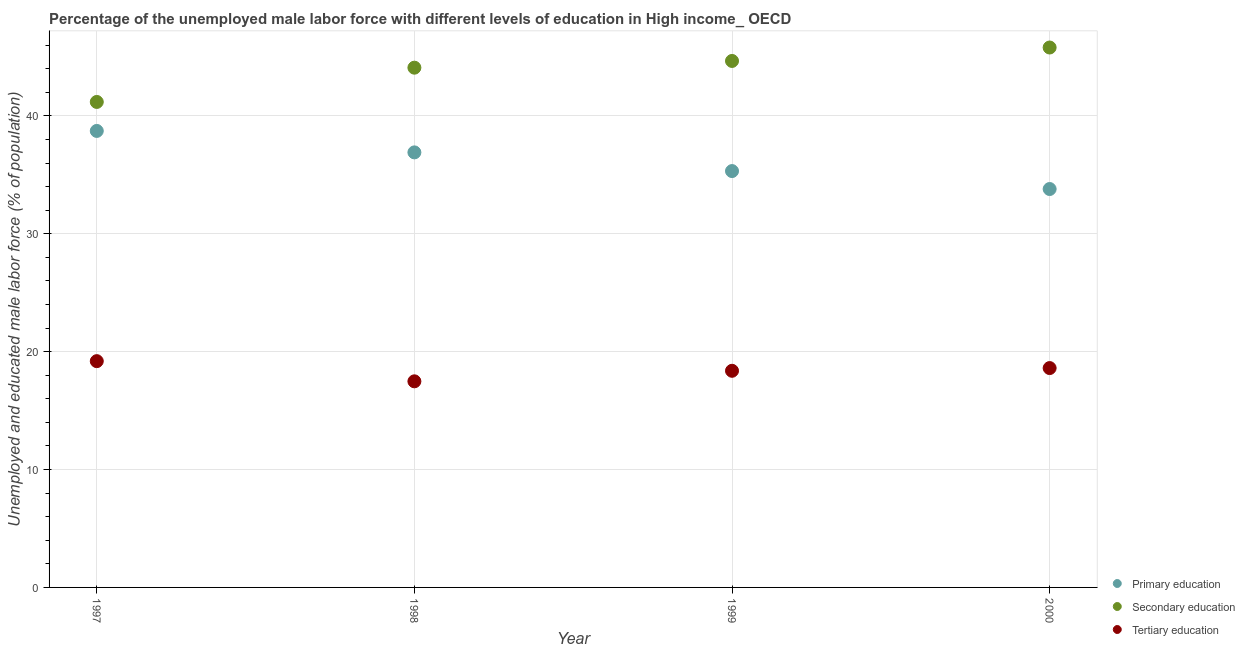Is the number of dotlines equal to the number of legend labels?
Ensure brevity in your answer.  Yes. What is the percentage of male labor force who received secondary education in 2000?
Make the answer very short. 45.8. Across all years, what is the maximum percentage of male labor force who received secondary education?
Provide a short and direct response. 45.8. Across all years, what is the minimum percentage of male labor force who received tertiary education?
Make the answer very short. 17.48. What is the total percentage of male labor force who received secondary education in the graph?
Provide a succinct answer. 175.74. What is the difference between the percentage of male labor force who received primary education in 1998 and that in 2000?
Provide a succinct answer. 3.11. What is the difference between the percentage of male labor force who received primary education in 1997 and the percentage of male labor force who received secondary education in 1999?
Your answer should be compact. -5.94. What is the average percentage of male labor force who received secondary education per year?
Your answer should be compact. 43.93. In the year 1997, what is the difference between the percentage of male labor force who received tertiary education and percentage of male labor force who received secondary education?
Your answer should be very brief. -21.99. In how many years, is the percentage of male labor force who received tertiary education greater than 24 %?
Give a very brief answer. 0. What is the ratio of the percentage of male labor force who received tertiary education in 1998 to that in 1999?
Ensure brevity in your answer.  0.95. Is the percentage of male labor force who received secondary education in 1997 less than that in 1999?
Your answer should be compact. Yes. What is the difference between the highest and the second highest percentage of male labor force who received primary education?
Give a very brief answer. 1.82. What is the difference between the highest and the lowest percentage of male labor force who received primary education?
Offer a very short reply. 4.93. In how many years, is the percentage of male labor force who received secondary education greater than the average percentage of male labor force who received secondary education taken over all years?
Offer a terse response. 3. Is the sum of the percentage of male labor force who received primary education in 1997 and 1998 greater than the maximum percentage of male labor force who received tertiary education across all years?
Provide a succinct answer. Yes. Is it the case that in every year, the sum of the percentage of male labor force who received primary education and percentage of male labor force who received secondary education is greater than the percentage of male labor force who received tertiary education?
Ensure brevity in your answer.  Yes. Is the percentage of male labor force who received primary education strictly greater than the percentage of male labor force who received tertiary education over the years?
Give a very brief answer. Yes. How many years are there in the graph?
Ensure brevity in your answer.  4. Are the values on the major ticks of Y-axis written in scientific E-notation?
Give a very brief answer. No. How many legend labels are there?
Offer a very short reply. 3. How are the legend labels stacked?
Ensure brevity in your answer.  Vertical. What is the title of the graph?
Provide a short and direct response. Percentage of the unemployed male labor force with different levels of education in High income_ OECD. What is the label or title of the Y-axis?
Offer a very short reply. Unemployed and educated male labor force (% of population). What is the Unemployed and educated male labor force (% of population) in Primary education in 1997?
Your response must be concise. 38.73. What is the Unemployed and educated male labor force (% of population) in Secondary education in 1997?
Make the answer very short. 41.18. What is the Unemployed and educated male labor force (% of population) in Tertiary education in 1997?
Your response must be concise. 19.2. What is the Unemployed and educated male labor force (% of population) in Primary education in 1998?
Your response must be concise. 36.91. What is the Unemployed and educated male labor force (% of population) in Secondary education in 1998?
Offer a terse response. 44.09. What is the Unemployed and educated male labor force (% of population) in Tertiary education in 1998?
Your answer should be compact. 17.48. What is the Unemployed and educated male labor force (% of population) of Primary education in 1999?
Give a very brief answer. 35.32. What is the Unemployed and educated male labor force (% of population) in Secondary education in 1999?
Give a very brief answer. 44.66. What is the Unemployed and educated male labor force (% of population) in Tertiary education in 1999?
Ensure brevity in your answer.  18.38. What is the Unemployed and educated male labor force (% of population) of Primary education in 2000?
Keep it short and to the point. 33.8. What is the Unemployed and educated male labor force (% of population) in Secondary education in 2000?
Provide a short and direct response. 45.8. What is the Unemployed and educated male labor force (% of population) of Tertiary education in 2000?
Provide a short and direct response. 18.61. Across all years, what is the maximum Unemployed and educated male labor force (% of population) of Primary education?
Your response must be concise. 38.73. Across all years, what is the maximum Unemployed and educated male labor force (% of population) of Secondary education?
Keep it short and to the point. 45.8. Across all years, what is the maximum Unemployed and educated male labor force (% of population) of Tertiary education?
Keep it short and to the point. 19.2. Across all years, what is the minimum Unemployed and educated male labor force (% of population) of Primary education?
Offer a very short reply. 33.8. Across all years, what is the minimum Unemployed and educated male labor force (% of population) of Secondary education?
Give a very brief answer. 41.18. Across all years, what is the minimum Unemployed and educated male labor force (% of population) in Tertiary education?
Provide a short and direct response. 17.48. What is the total Unemployed and educated male labor force (% of population) in Primary education in the graph?
Keep it short and to the point. 144.75. What is the total Unemployed and educated male labor force (% of population) in Secondary education in the graph?
Ensure brevity in your answer.  175.74. What is the total Unemployed and educated male labor force (% of population) of Tertiary education in the graph?
Your response must be concise. 73.67. What is the difference between the Unemployed and educated male labor force (% of population) of Primary education in 1997 and that in 1998?
Ensure brevity in your answer.  1.82. What is the difference between the Unemployed and educated male labor force (% of population) of Secondary education in 1997 and that in 1998?
Give a very brief answer. -2.91. What is the difference between the Unemployed and educated male labor force (% of population) in Tertiary education in 1997 and that in 1998?
Ensure brevity in your answer.  1.71. What is the difference between the Unemployed and educated male labor force (% of population) in Primary education in 1997 and that in 1999?
Your response must be concise. 3.41. What is the difference between the Unemployed and educated male labor force (% of population) of Secondary education in 1997 and that in 1999?
Your answer should be compact. -3.48. What is the difference between the Unemployed and educated male labor force (% of population) in Tertiary education in 1997 and that in 1999?
Your answer should be compact. 0.82. What is the difference between the Unemployed and educated male labor force (% of population) in Primary education in 1997 and that in 2000?
Give a very brief answer. 4.93. What is the difference between the Unemployed and educated male labor force (% of population) of Secondary education in 1997 and that in 2000?
Your answer should be compact. -4.62. What is the difference between the Unemployed and educated male labor force (% of population) of Tertiary education in 1997 and that in 2000?
Offer a very short reply. 0.59. What is the difference between the Unemployed and educated male labor force (% of population) in Primary education in 1998 and that in 1999?
Give a very brief answer. 1.59. What is the difference between the Unemployed and educated male labor force (% of population) of Secondary education in 1998 and that in 1999?
Make the answer very short. -0.57. What is the difference between the Unemployed and educated male labor force (% of population) of Tertiary education in 1998 and that in 1999?
Offer a terse response. -0.89. What is the difference between the Unemployed and educated male labor force (% of population) of Primary education in 1998 and that in 2000?
Ensure brevity in your answer.  3.11. What is the difference between the Unemployed and educated male labor force (% of population) of Secondary education in 1998 and that in 2000?
Ensure brevity in your answer.  -1.71. What is the difference between the Unemployed and educated male labor force (% of population) in Tertiary education in 1998 and that in 2000?
Provide a short and direct response. -1.12. What is the difference between the Unemployed and educated male labor force (% of population) in Primary education in 1999 and that in 2000?
Your answer should be very brief. 1.52. What is the difference between the Unemployed and educated male labor force (% of population) in Secondary education in 1999 and that in 2000?
Provide a succinct answer. -1.14. What is the difference between the Unemployed and educated male labor force (% of population) of Tertiary education in 1999 and that in 2000?
Offer a very short reply. -0.23. What is the difference between the Unemployed and educated male labor force (% of population) in Primary education in 1997 and the Unemployed and educated male labor force (% of population) in Secondary education in 1998?
Your answer should be very brief. -5.37. What is the difference between the Unemployed and educated male labor force (% of population) of Primary education in 1997 and the Unemployed and educated male labor force (% of population) of Tertiary education in 1998?
Your answer should be compact. 21.24. What is the difference between the Unemployed and educated male labor force (% of population) of Secondary education in 1997 and the Unemployed and educated male labor force (% of population) of Tertiary education in 1998?
Ensure brevity in your answer.  23.7. What is the difference between the Unemployed and educated male labor force (% of population) in Primary education in 1997 and the Unemployed and educated male labor force (% of population) in Secondary education in 1999?
Provide a succinct answer. -5.94. What is the difference between the Unemployed and educated male labor force (% of population) of Primary education in 1997 and the Unemployed and educated male labor force (% of population) of Tertiary education in 1999?
Ensure brevity in your answer.  20.35. What is the difference between the Unemployed and educated male labor force (% of population) of Secondary education in 1997 and the Unemployed and educated male labor force (% of population) of Tertiary education in 1999?
Keep it short and to the point. 22.81. What is the difference between the Unemployed and educated male labor force (% of population) of Primary education in 1997 and the Unemployed and educated male labor force (% of population) of Secondary education in 2000?
Ensure brevity in your answer.  -7.08. What is the difference between the Unemployed and educated male labor force (% of population) of Primary education in 1997 and the Unemployed and educated male labor force (% of population) of Tertiary education in 2000?
Make the answer very short. 20.12. What is the difference between the Unemployed and educated male labor force (% of population) of Secondary education in 1997 and the Unemployed and educated male labor force (% of population) of Tertiary education in 2000?
Provide a short and direct response. 22.58. What is the difference between the Unemployed and educated male labor force (% of population) in Primary education in 1998 and the Unemployed and educated male labor force (% of population) in Secondary education in 1999?
Your answer should be compact. -7.76. What is the difference between the Unemployed and educated male labor force (% of population) in Primary education in 1998 and the Unemployed and educated male labor force (% of population) in Tertiary education in 1999?
Offer a terse response. 18.53. What is the difference between the Unemployed and educated male labor force (% of population) of Secondary education in 1998 and the Unemployed and educated male labor force (% of population) of Tertiary education in 1999?
Make the answer very short. 25.71. What is the difference between the Unemployed and educated male labor force (% of population) in Primary education in 1998 and the Unemployed and educated male labor force (% of population) in Secondary education in 2000?
Ensure brevity in your answer.  -8.9. What is the difference between the Unemployed and educated male labor force (% of population) in Primary education in 1998 and the Unemployed and educated male labor force (% of population) in Tertiary education in 2000?
Your answer should be compact. 18.3. What is the difference between the Unemployed and educated male labor force (% of population) of Secondary education in 1998 and the Unemployed and educated male labor force (% of population) of Tertiary education in 2000?
Your response must be concise. 25.48. What is the difference between the Unemployed and educated male labor force (% of population) of Primary education in 1999 and the Unemployed and educated male labor force (% of population) of Secondary education in 2000?
Your answer should be compact. -10.48. What is the difference between the Unemployed and educated male labor force (% of population) in Primary education in 1999 and the Unemployed and educated male labor force (% of population) in Tertiary education in 2000?
Offer a terse response. 16.71. What is the difference between the Unemployed and educated male labor force (% of population) in Secondary education in 1999 and the Unemployed and educated male labor force (% of population) in Tertiary education in 2000?
Provide a succinct answer. 26.05. What is the average Unemployed and educated male labor force (% of population) in Primary education per year?
Give a very brief answer. 36.19. What is the average Unemployed and educated male labor force (% of population) of Secondary education per year?
Your answer should be compact. 43.93. What is the average Unemployed and educated male labor force (% of population) in Tertiary education per year?
Give a very brief answer. 18.42. In the year 1997, what is the difference between the Unemployed and educated male labor force (% of population) in Primary education and Unemployed and educated male labor force (% of population) in Secondary education?
Your response must be concise. -2.46. In the year 1997, what is the difference between the Unemployed and educated male labor force (% of population) of Primary education and Unemployed and educated male labor force (% of population) of Tertiary education?
Ensure brevity in your answer.  19.53. In the year 1997, what is the difference between the Unemployed and educated male labor force (% of population) of Secondary education and Unemployed and educated male labor force (% of population) of Tertiary education?
Offer a very short reply. 21.99. In the year 1998, what is the difference between the Unemployed and educated male labor force (% of population) in Primary education and Unemployed and educated male labor force (% of population) in Secondary education?
Your answer should be very brief. -7.19. In the year 1998, what is the difference between the Unemployed and educated male labor force (% of population) in Primary education and Unemployed and educated male labor force (% of population) in Tertiary education?
Offer a very short reply. 19.42. In the year 1998, what is the difference between the Unemployed and educated male labor force (% of population) in Secondary education and Unemployed and educated male labor force (% of population) in Tertiary education?
Provide a succinct answer. 26.61. In the year 1999, what is the difference between the Unemployed and educated male labor force (% of population) in Primary education and Unemployed and educated male labor force (% of population) in Secondary education?
Offer a terse response. -9.34. In the year 1999, what is the difference between the Unemployed and educated male labor force (% of population) of Primary education and Unemployed and educated male labor force (% of population) of Tertiary education?
Offer a very short reply. 16.94. In the year 1999, what is the difference between the Unemployed and educated male labor force (% of population) of Secondary education and Unemployed and educated male labor force (% of population) of Tertiary education?
Your answer should be compact. 26.28. In the year 2000, what is the difference between the Unemployed and educated male labor force (% of population) of Primary education and Unemployed and educated male labor force (% of population) of Secondary education?
Provide a succinct answer. -12. In the year 2000, what is the difference between the Unemployed and educated male labor force (% of population) in Primary education and Unemployed and educated male labor force (% of population) in Tertiary education?
Offer a terse response. 15.19. In the year 2000, what is the difference between the Unemployed and educated male labor force (% of population) of Secondary education and Unemployed and educated male labor force (% of population) of Tertiary education?
Offer a terse response. 27.19. What is the ratio of the Unemployed and educated male labor force (% of population) of Primary education in 1997 to that in 1998?
Offer a terse response. 1.05. What is the ratio of the Unemployed and educated male labor force (% of population) of Secondary education in 1997 to that in 1998?
Keep it short and to the point. 0.93. What is the ratio of the Unemployed and educated male labor force (% of population) in Tertiary education in 1997 to that in 1998?
Your response must be concise. 1.1. What is the ratio of the Unemployed and educated male labor force (% of population) in Primary education in 1997 to that in 1999?
Your answer should be very brief. 1.1. What is the ratio of the Unemployed and educated male labor force (% of population) of Secondary education in 1997 to that in 1999?
Keep it short and to the point. 0.92. What is the ratio of the Unemployed and educated male labor force (% of population) of Tertiary education in 1997 to that in 1999?
Offer a very short reply. 1.04. What is the ratio of the Unemployed and educated male labor force (% of population) in Primary education in 1997 to that in 2000?
Your response must be concise. 1.15. What is the ratio of the Unemployed and educated male labor force (% of population) in Secondary education in 1997 to that in 2000?
Make the answer very short. 0.9. What is the ratio of the Unemployed and educated male labor force (% of population) of Tertiary education in 1997 to that in 2000?
Your answer should be very brief. 1.03. What is the ratio of the Unemployed and educated male labor force (% of population) of Primary education in 1998 to that in 1999?
Make the answer very short. 1.04. What is the ratio of the Unemployed and educated male labor force (% of population) of Secondary education in 1998 to that in 1999?
Keep it short and to the point. 0.99. What is the ratio of the Unemployed and educated male labor force (% of population) of Tertiary education in 1998 to that in 1999?
Keep it short and to the point. 0.95. What is the ratio of the Unemployed and educated male labor force (% of population) of Primary education in 1998 to that in 2000?
Provide a succinct answer. 1.09. What is the ratio of the Unemployed and educated male labor force (% of population) of Secondary education in 1998 to that in 2000?
Provide a succinct answer. 0.96. What is the ratio of the Unemployed and educated male labor force (% of population) in Tertiary education in 1998 to that in 2000?
Ensure brevity in your answer.  0.94. What is the ratio of the Unemployed and educated male labor force (% of population) in Primary education in 1999 to that in 2000?
Provide a succinct answer. 1.05. What is the ratio of the Unemployed and educated male labor force (% of population) in Secondary education in 1999 to that in 2000?
Keep it short and to the point. 0.98. What is the ratio of the Unemployed and educated male labor force (% of population) in Tertiary education in 1999 to that in 2000?
Your answer should be compact. 0.99. What is the difference between the highest and the second highest Unemployed and educated male labor force (% of population) of Primary education?
Offer a terse response. 1.82. What is the difference between the highest and the second highest Unemployed and educated male labor force (% of population) in Secondary education?
Give a very brief answer. 1.14. What is the difference between the highest and the second highest Unemployed and educated male labor force (% of population) of Tertiary education?
Your answer should be very brief. 0.59. What is the difference between the highest and the lowest Unemployed and educated male labor force (% of population) of Primary education?
Make the answer very short. 4.93. What is the difference between the highest and the lowest Unemployed and educated male labor force (% of population) in Secondary education?
Keep it short and to the point. 4.62. What is the difference between the highest and the lowest Unemployed and educated male labor force (% of population) in Tertiary education?
Ensure brevity in your answer.  1.71. 